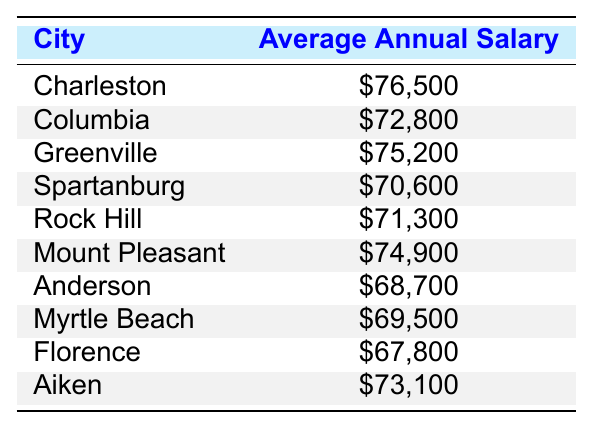What is the average annual salary of mechanical engineers in Charleston? The table indicates that the average annual salary for mechanical engineers in Charleston is $76,500.
Answer: $76,500 Which city has the lowest average annual salary for mechanical engineers? By looking through the table, we can see that Florence has the lowest average annual salary at $67,800.
Answer: Florence Calculate the difference in average annual salary between Greenville and Spartanburg. Greenville's average salary is $75,200 and Spartanburg's is $70,600. The difference is $75,200 - $70,600 = $4,600.
Answer: $4,600 What is the average annual salary for the cities listed in this table? We add up all the average salaries and divide by the number of cities. The total is $76,500 + $72,800 + $75,200 + $70,600 + $71,300 + $74,900 + $68,700 + $69,500 + $67,800 + $73,100 = $740,600. There are 10 cities, so the average is $740,600 / 10 = $74,060.
Answer: $74,060 Is the average annual salary in Mount Pleasant greater than that in Aiken? Mount Pleasant's average salary is $74,900 and Aiken's is $73,100. Since $74,900 is greater than $73,100, the answer is yes.
Answer: Yes How many cities have an average salary above $72,000? Examining the table, we see that the following cities have salaries above $72,000: Charleston, Greenville, Mount Pleasant, and Aiken. That totals to 4 cities.
Answer: 4 Which two cities have the closest average annual salaries? We compare the salaries: Rock Hill ($71,300), Spartanburg ($70,600), and Anderson ($68,700). The closest salaries are Rock Hill and Spartanburg with a difference of $1,700, which is the smallest among all pairs.
Answer: Rock Hill and Spartanburg If we include average salaries of Columbia and Myrtle Beach, what would be the average of these three cities: Columbia, Myrtle Beach, and Aiken? First, we find their salaries: Columbia - $72,800, Myrtle Beach - $69,500, and Aiken - $73,100. The total is $72,800 + $69,500 + $73,100 = $215,400, and dividing this by 3 gives an average of $215,400 / 3 = $71,800.
Answer: $71,800 Is there a city in South Carolina where the average salary is below $70,000? The table lists Florence ($67,800) and Anderson ($68,700), both of which have salaries below $70,000, confirming that there are cities below this threshold.
Answer: Yes 